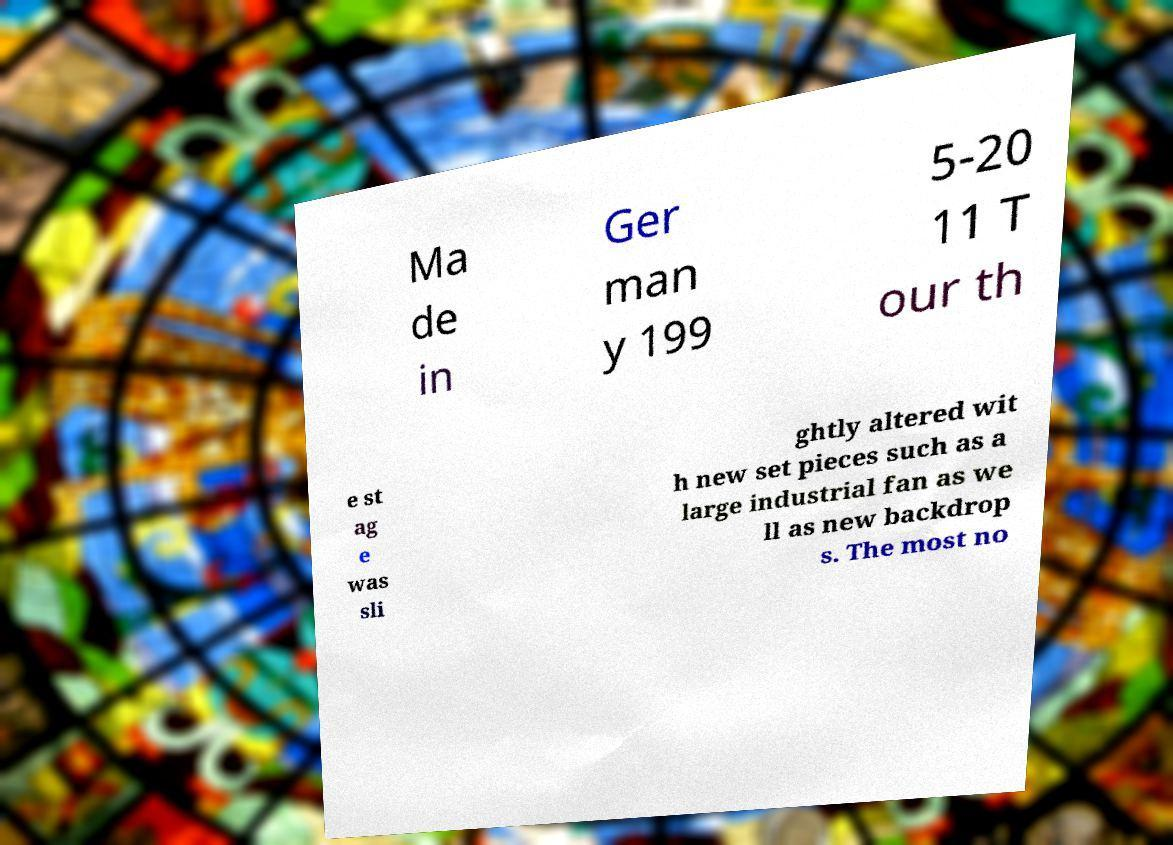What messages or text are displayed in this image? I need them in a readable, typed format. Ma de in Ger man y 199 5-20 11 T our th e st ag e was sli ghtly altered wit h new set pieces such as a large industrial fan as we ll as new backdrop s. The most no 